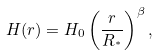Convert formula to latex. <formula><loc_0><loc_0><loc_500><loc_500>H ( r ) = H _ { 0 } \left ( \frac { r } { R _ { ^ { * } } } \right ) ^ { \beta } ,</formula> 